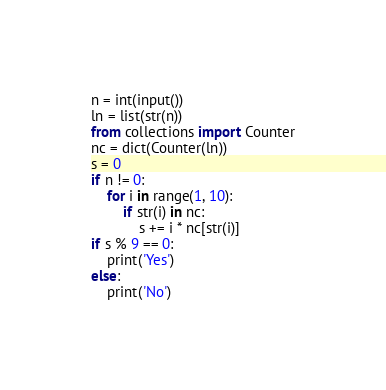Convert code to text. <code><loc_0><loc_0><loc_500><loc_500><_Python_>n = int(input())
ln = list(str(n))
from collections import Counter
nc = dict(Counter(ln))
s = 0
if n != 0:
    for i in range(1, 10):
        if str(i) in nc:
            s += i * nc[str(i)]
if s % 9 == 0:
    print('Yes')
else:
    print('No')</code> 